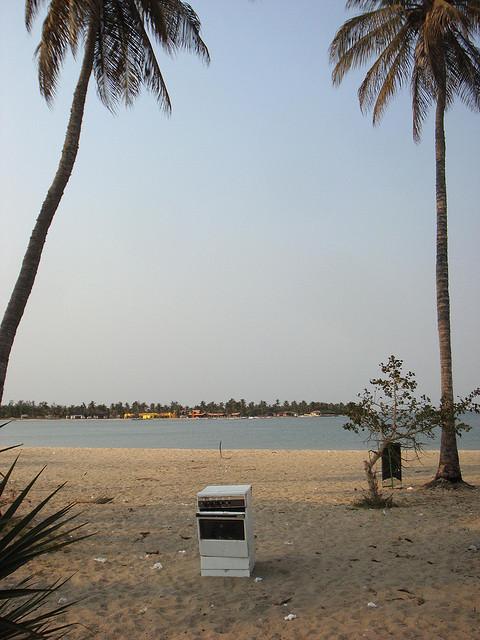What kind of trees are these?
Write a very short answer. Palm. Is the object in the foreground typically found on a beach?
Give a very brief answer. No. Does this ground easy to walk on barefoot?
Concise answer only. Yes. 